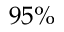Convert formula to latex. <formula><loc_0><loc_0><loc_500><loc_500>9 5 \%</formula> 